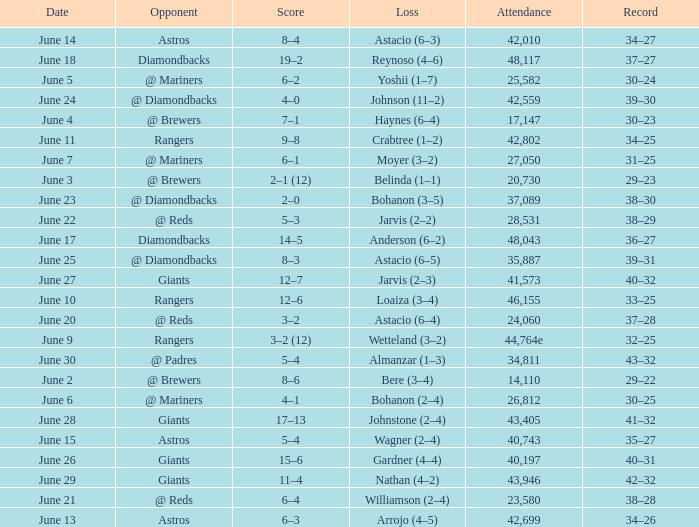What's the record when the attendance was 28,531? 38–29. 